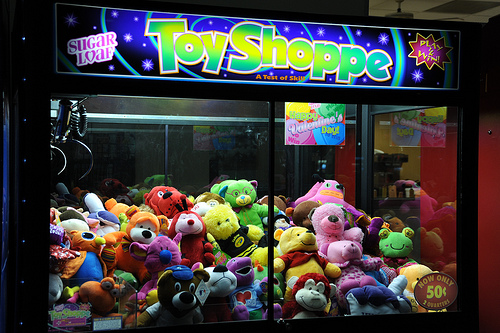<image>
Is the toy under the sign? Yes. The toy is positioned underneath the sign, with the sign above it in the vertical space. 